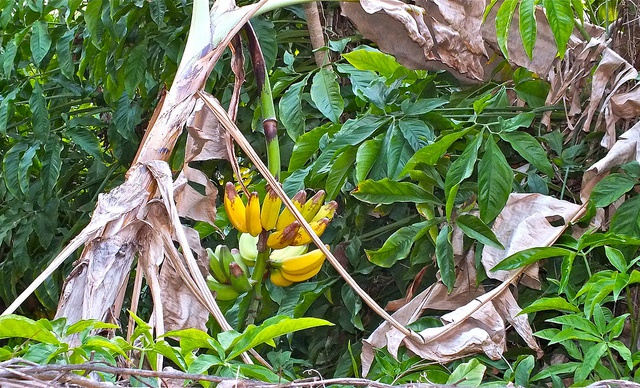Describe the objects in this image and their specific colors. I can see a banana in green, gold, olive, and beige tones in this image. 